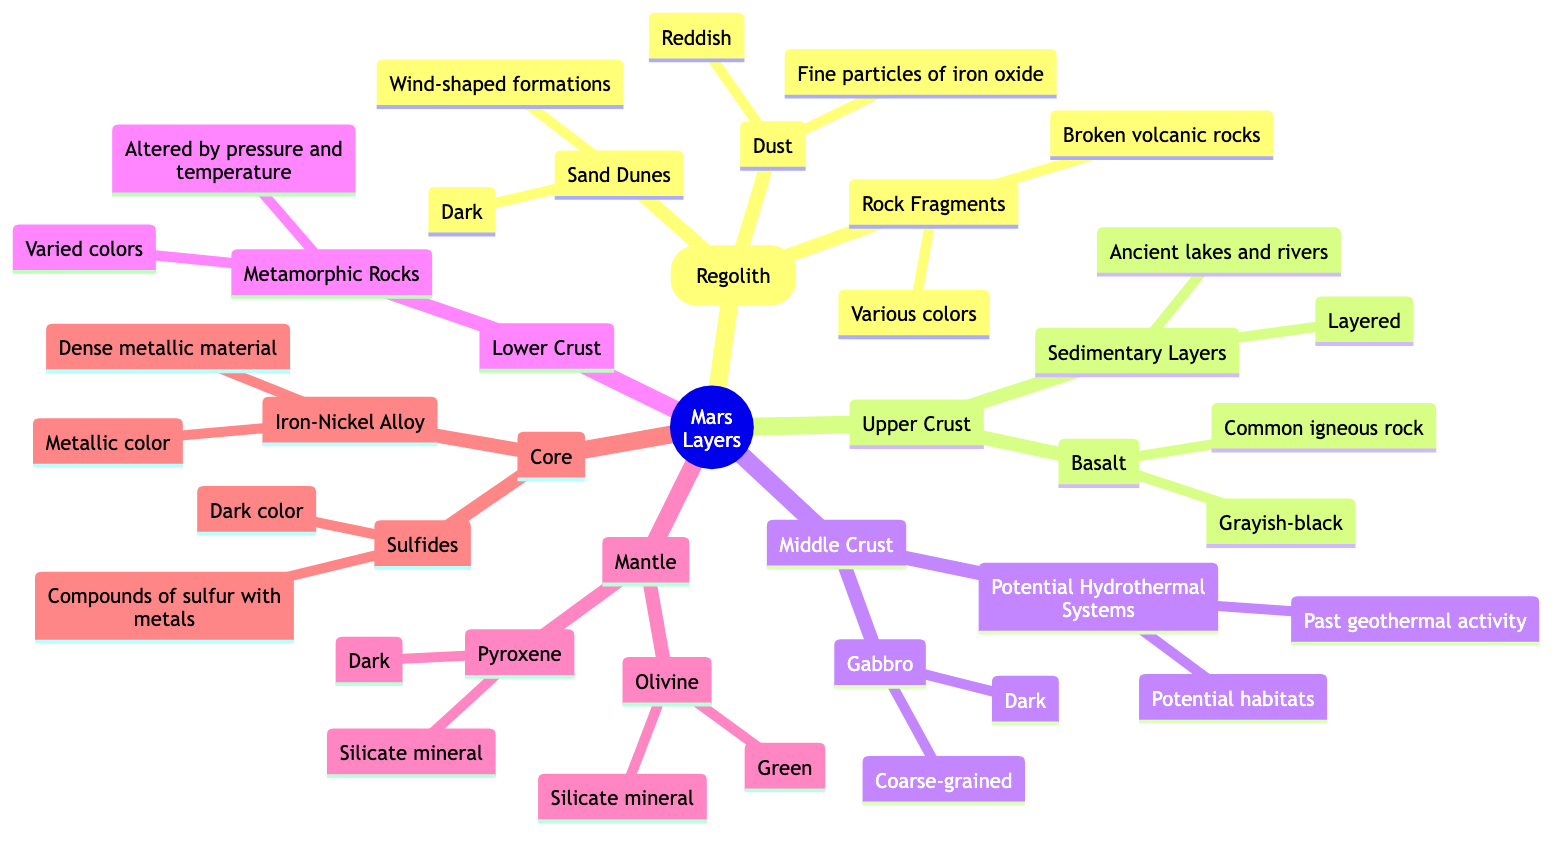What is the primary mineral found in the mantle? The diagram indicates that the mantle contains Olivine, which is the silicate mineral labeled specifically within the mantle section.
Answer: Olivine How many layers are present in Mars' subsurface according to the diagram? The diagram shows five distinct layers below the surface layer: Upper Crust, Middle Crust, Lower Crust, Mantle, and Core. This counts to four subsurface layers.
Answer: Four What color is basalt in the Upper Crust? The Upper Crust section of the diagram specifies that basalt is grayish-black, indicating its distinctive color as described.
Answer: Grayish-black What type of rocks are formed under pressure in the Lower Crust? The diagram details that the Lower Crust consists of Metamorphic Rocks, which are explicitly labeled as altered by pressure and temperature, indicating their nature.
Answer: Metamorphic Rocks Which layer contains potential habitats for microbial life? In the diagram, the Middle Crust is identified as having Potential Hydrothermal Systems, which are noted as potential habitats due to past geothermal activity.
Answer: Middle Crust What mineral in the Mantle is described as dark? The diagram specifies that Pyroxene, a silicate mineral found in the Mantle, is characterized as dark in color, making it the answer to the question.
Answer: Pyroxene What type of rock is primarily found in the Surface Layer? The diagram indicates that the Surface Layer, also called Regolith, mainly consists of Dust, Sand Dunes, and Rock Fragments, with the most fundamental type being defined generally as regolith.
Answer: Regolith How are the sedimentary layers in the Upper Crust characterized? The diagram describes the sedimentary layers as layered, indicating a specific feature of these structures in the Upper Crust.
Answer: Layered 